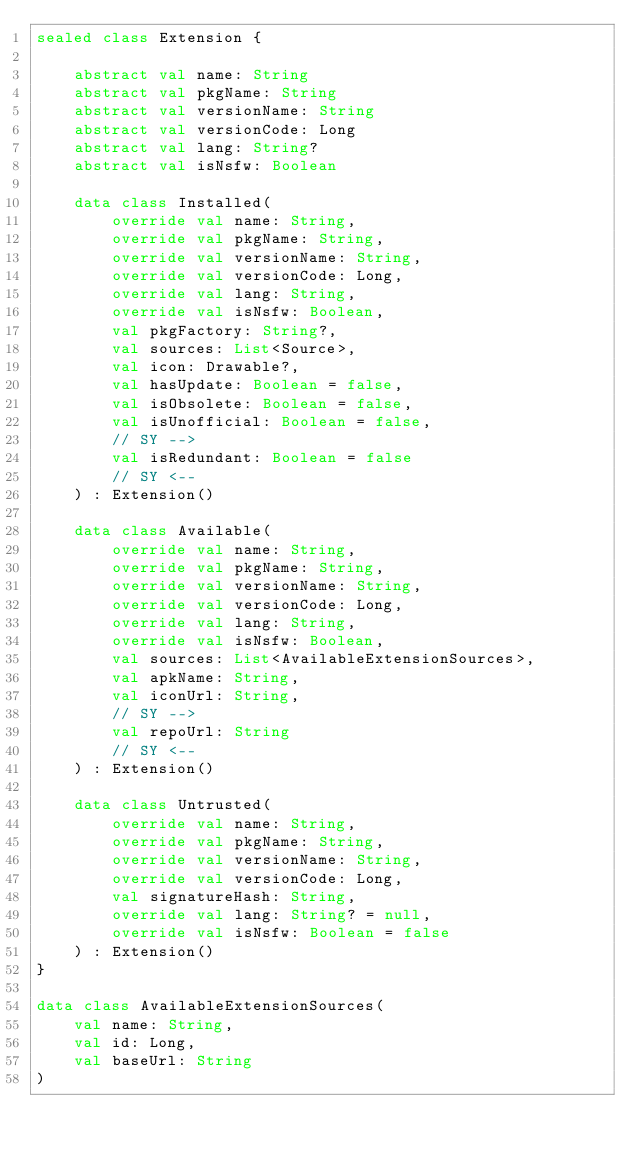Convert code to text. <code><loc_0><loc_0><loc_500><loc_500><_Kotlin_>sealed class Extension {

    abstract val name: String
    abstract val pkgName: String
    abstract val versionName: String
    abstract val versionCode: Long
    abstract val lang: String?
    abstract val isNsfw: Boolean

    data class Installed(
        override val name: String,
        override val pkgName: String,
        override val versionName: String,
        override val versionCode: Long,
        override val lang: String,
        override val isNsfw: Boolean,
        val pkgFactory: String?,
        val sources: List<Source>,
        val icon: Drawable?,
        val hasUpdate: Boolean = false,
        val isObsolete: Boolean = false,
        val isUnofficial: Boolean = false,
        // SY -->
        val isRedundant: Boolean = false
        // SY <--
    ) : Extension()

    data class Available(
        override val name: String,
        override val pkgName: String,
        override val versionName: String,
        override val versionCode: Long,
        override val lang: String,
        override val isNsfw: Boolean,
        val sources: List<AvailableExtensionSources>,
        val apkName: String,
        val iconUrl: String,
        // SY -->
        val repoUrl: String
        // SY <--
    ) : Extension()

    data class Untrusted(
        override val name: String,
        override val pkgName: String,
        override val versionName: String,
        override val versionCode: Long,
        val signatureHash: String,
        override val lang: String? = null,
        override val isNsfw: Boolean = false
    ) : Extension()
}

data class AvailableExtensionSources(
    val name: String,
    val id: Long,
    val baseUrl: String
)
</code> 